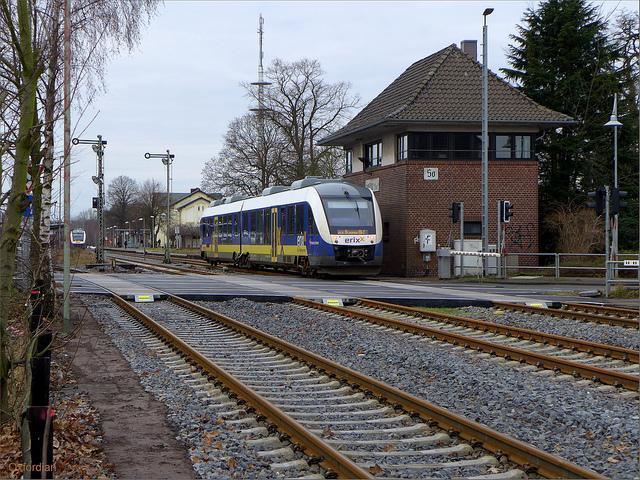How many tracks run here?
Give a very brief answer. 3. 